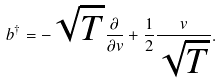<formula> <loc_0><loc_0><loc_500><loc_500>b ^ { \dagger } = - \sqrt { T } \frac { \partial } { \partial v } + \frac { 1 } { 2 } \frac { v } { \sqrt { T } } .</formula> 